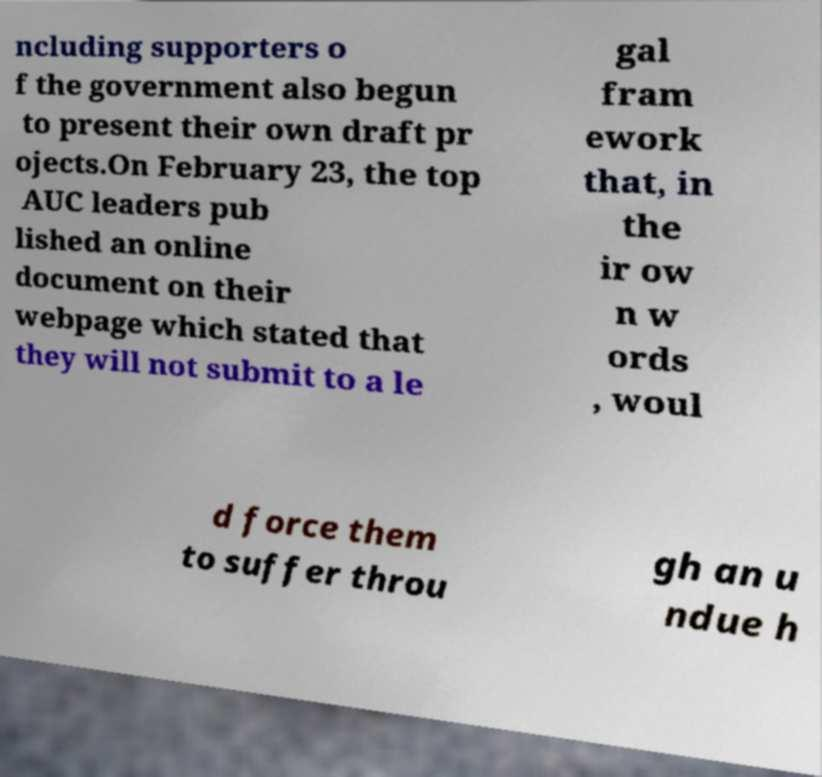There's text embedded in this image that I need extracted. Can you transcribe it verbatim? ncluding supporters o f the government also begun to present their own draft pr ojects.On February 23, the top AUC leaders pub lished an online document on their webpage which stated that they will not submit to a le gal fram ework that, in the ir ow n w ords , woul d force them to suffer throu gh an u ndue h 